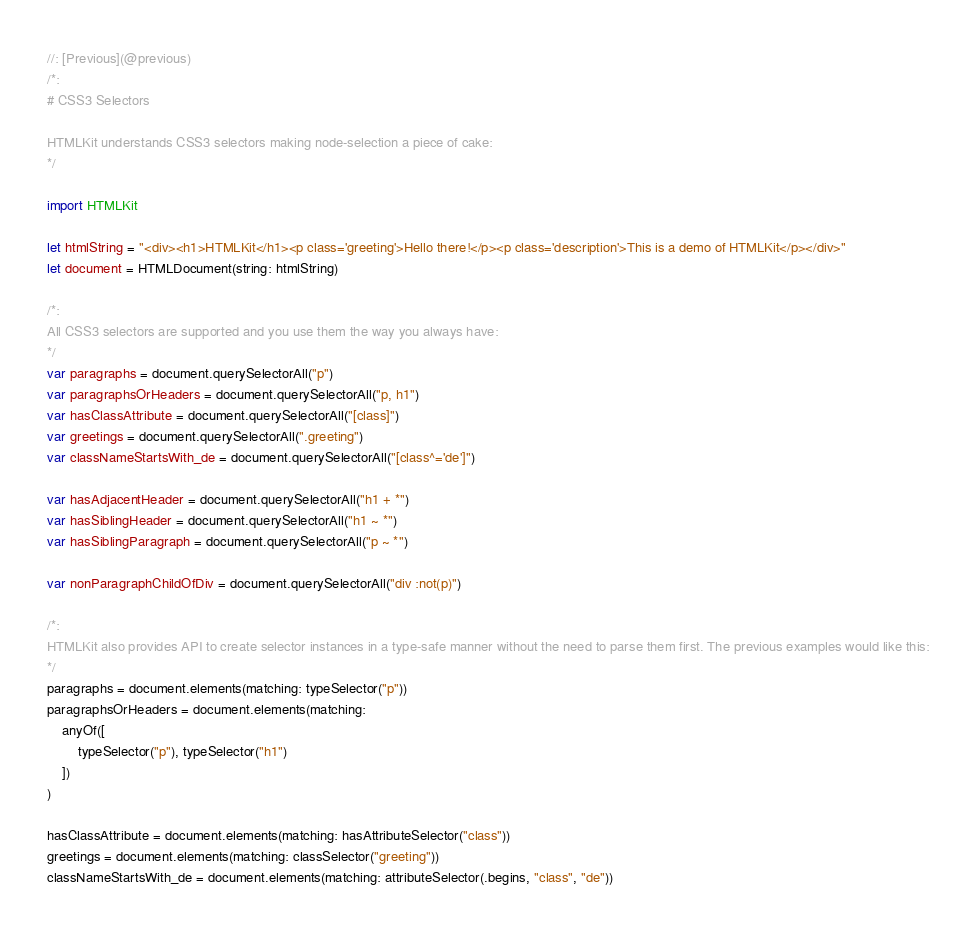<code> <loc_0><loc_0><loc_500><loc_500><_Swift_>//: [Previous](@previous)
/*:
# CSS3 Selectors

HTMLKit understands CSS3 selectors making node-selection a piece of cake:
*/

import HTMLKit

let htmlString = "<div><h1>HTMLKit</h1><p class='greeting'>Hello there!</p><p class='description'>This is a demo of HTMLKit</p></div>"
let document = HTMLDocument(string: htmlString)

/*:
All CSS3 selectors are supported and you use them the way you always have:
*/
var paragraphs = document.querySelectorAll("p")
var paragraphsOrHeaders = document.querySelectorAll("p, h1")
var hasClassAttribute = document.querySelectorAll("[class]")
var greetings = document.querySelectorAll(".greeting")
var classNameStartsWith_de = document.querySelectorAll("[class^='de']")

var hasAdjacentHeader = document.querySelectorAll("h1 + *")
var hasSiblingHeader = document.querySelectorAll("h1 ~ *")
var hasSiblingParagraph = document.querySelectorAll("p ~ *")

var nonParagraphChildOfDiv = document.querySelectorAll("div :not(p)")

/*:
HTMLKit also provides API to create selector instances in a type-safe manner without the need to parse them first. The previous examples would like this:
*/
paragraphs = document.elements(matching: typeSelector("p"))
paragraphsOrHeaders = document.elements(matching: 
	anyOf([
		typeSelector("p"), typeSelector("h1")
	])
)

hasClassAttribute = document.elements(matching: hasAttributeSelector("class"))
greetings = document.elements(matching: classSelector("greeting"))
classNameStartsWith_de = document.elements(matching: attributeSelector(.begins, "class", "de"))
</code> 